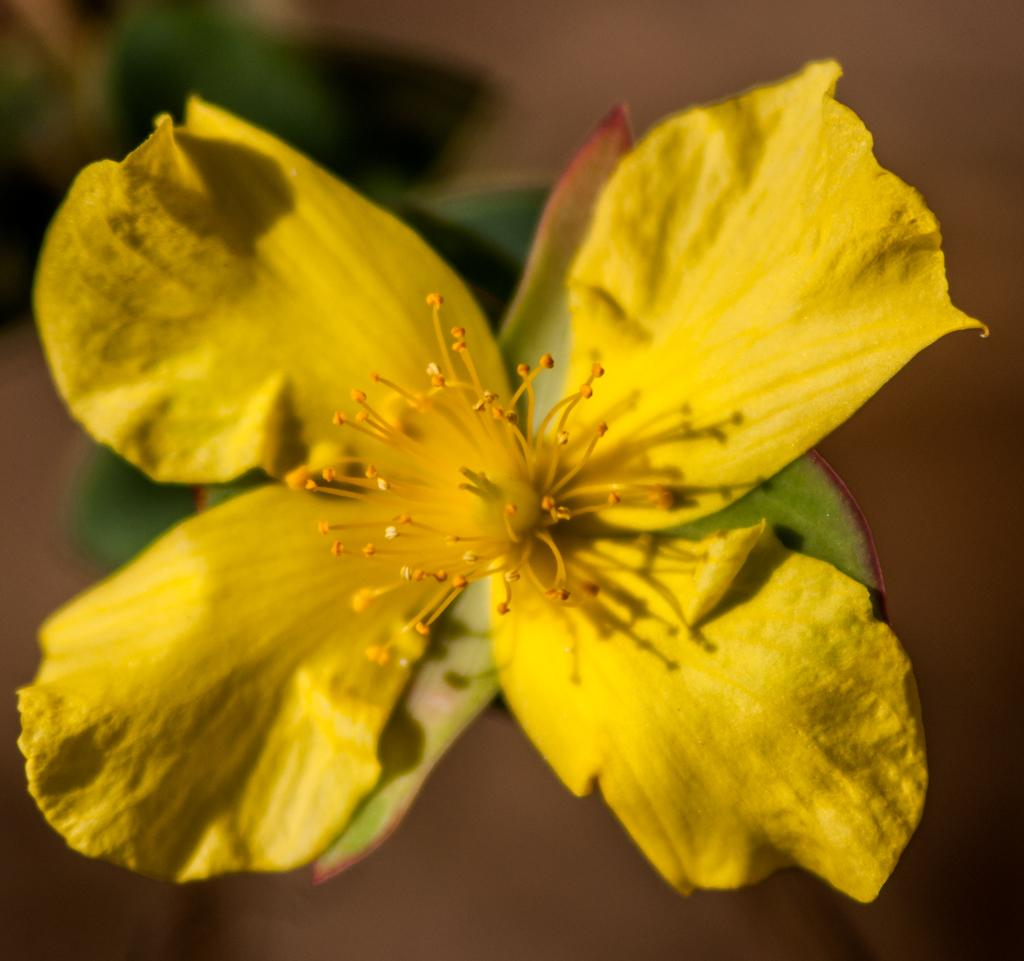What type of flower is present in the image? There is a yellow color flower in the image. What else can be seen in the image besides the flower? There are leaves in the image. How would you describe the background of the image? The background of the image is blurred. Can you see a gun in the image? No, there is no gun present in the image. What type of stick is visible in the image? There is no stick present in the image. 